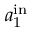Convert formula to latex. <formula><loc_0><loc_0><loc_500><loc_500>a _ { 1 } ^ { i n }</formula> 